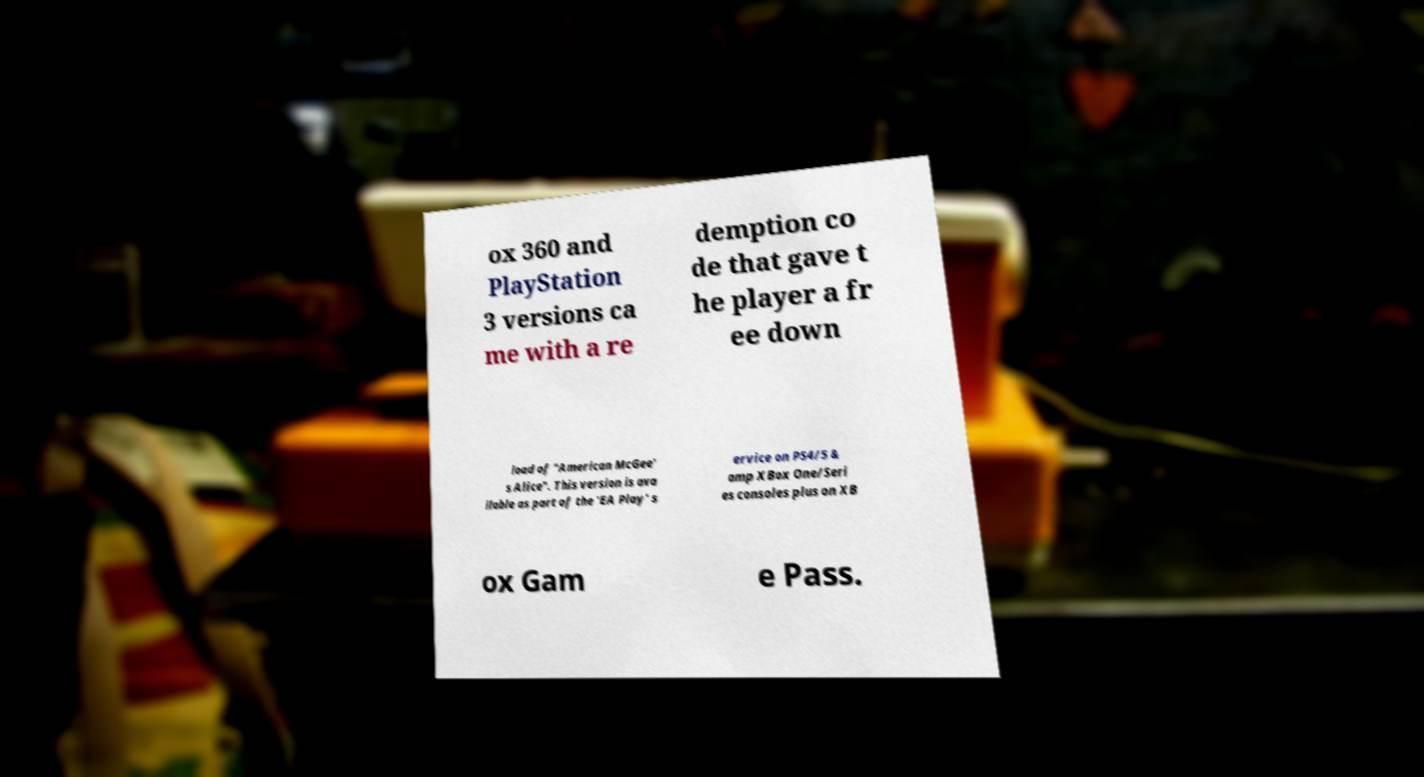Please read and relay the text visible in this image. What does it say? ox 360 and PlayStation 3 versions ca me with a re demption co de that gave t he player a fr ee down load of "American McGee' s Alice". This version is ava ilable as part of the 'EA Play' s ervice on PS4/5 & amp XBox One/Seri es consoles plus on XB ox Gam e Pass. 